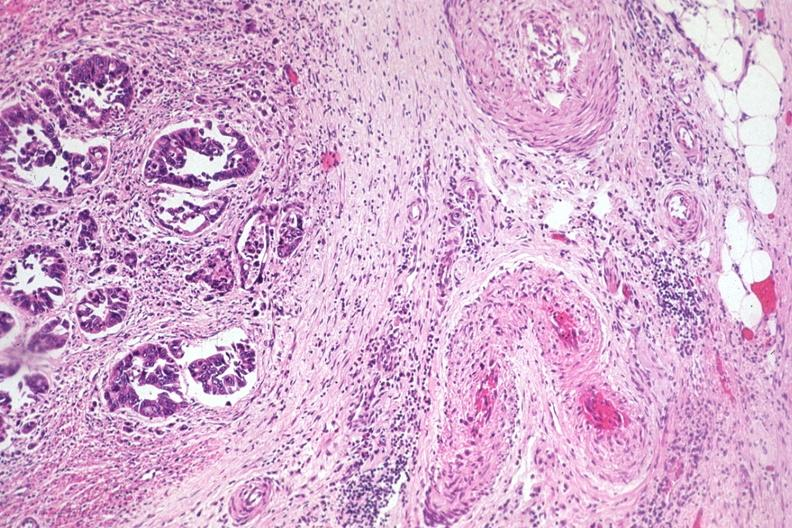s polycystic disease present?
Answer the question using a single word or phrase. No 